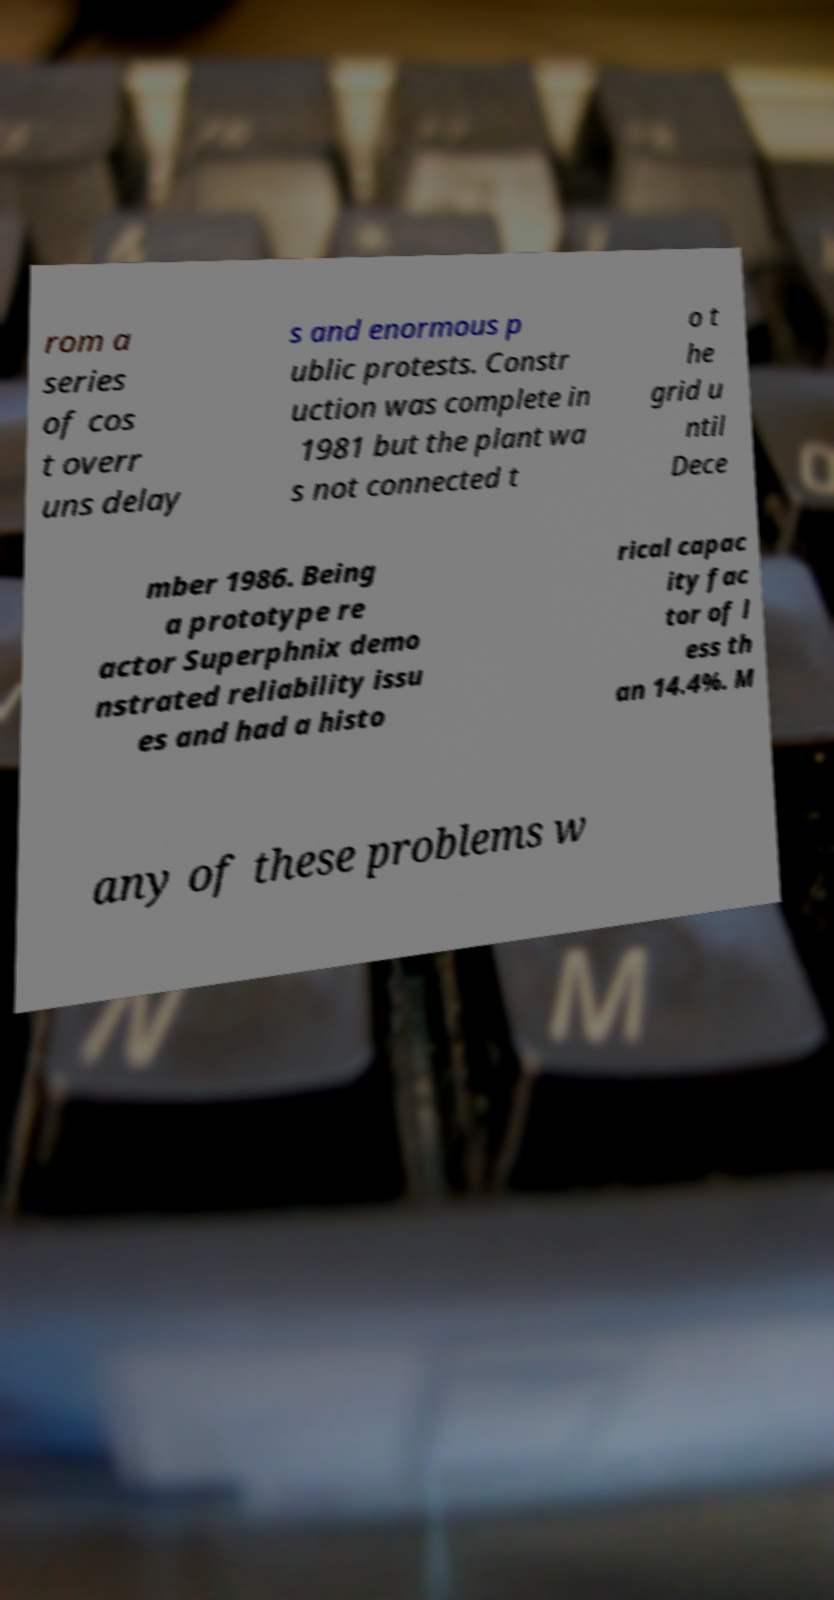Could you assist in decoding the text presented in this image and type it out clearly? rom a series of cos t overr uns delay s and enormous p ublic protests. Constr uction was complete in 1981 but the plant wa s not connected t o t he grid u ntil Dece mber 1986. Being a prototype re actor Superphnix demo nstrated reliability issu es and had a histo rical capac ity fac tor of l ess th an 14.4%. M any of these problems w 